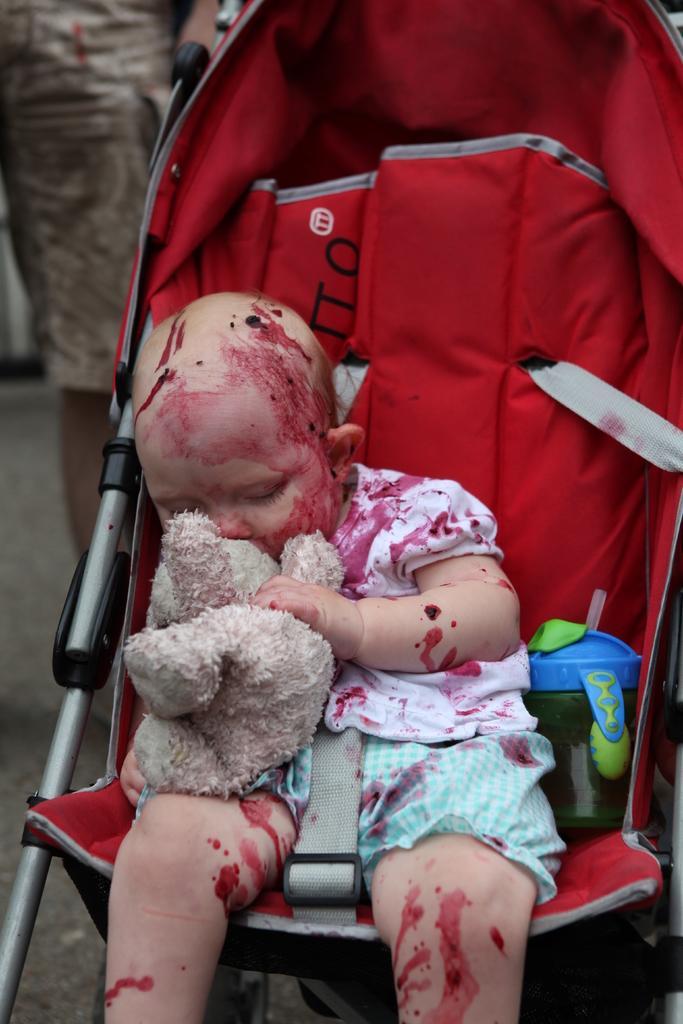How would you summarize this image in a sentence or two? In this image there is a baby holding a toy and sat on the walker and there is a blood on the body of a baby, beside him there is a water bottle. 